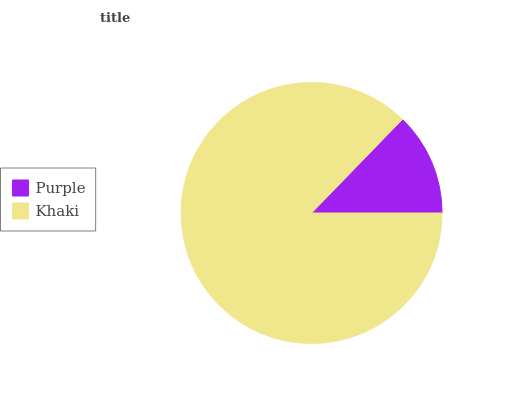Is Purple the minimum?
Answer yes or no. Yes. Is Khaki the maximum?
Answer yes or no. Yes. Is Khaki the minimum?
Answer yes or no. No. Is Khaki greater than Purple?
Answer yes or no. Yes. Is Purple less than Khaki?
Answer yes or no. Yes. Is Purple greater than Khaki?
Answer yes or no. No. Is Khaki less than Purple?
Answer yes or no. No. Is Khaki the high median?
Answer yes or no. Yes. Is Purple the low median?
Answer yes or no. Yes. Is Purple the high median?
Answer yes or no. No. Is Khaki the low median?
Answer yes or no. No. 